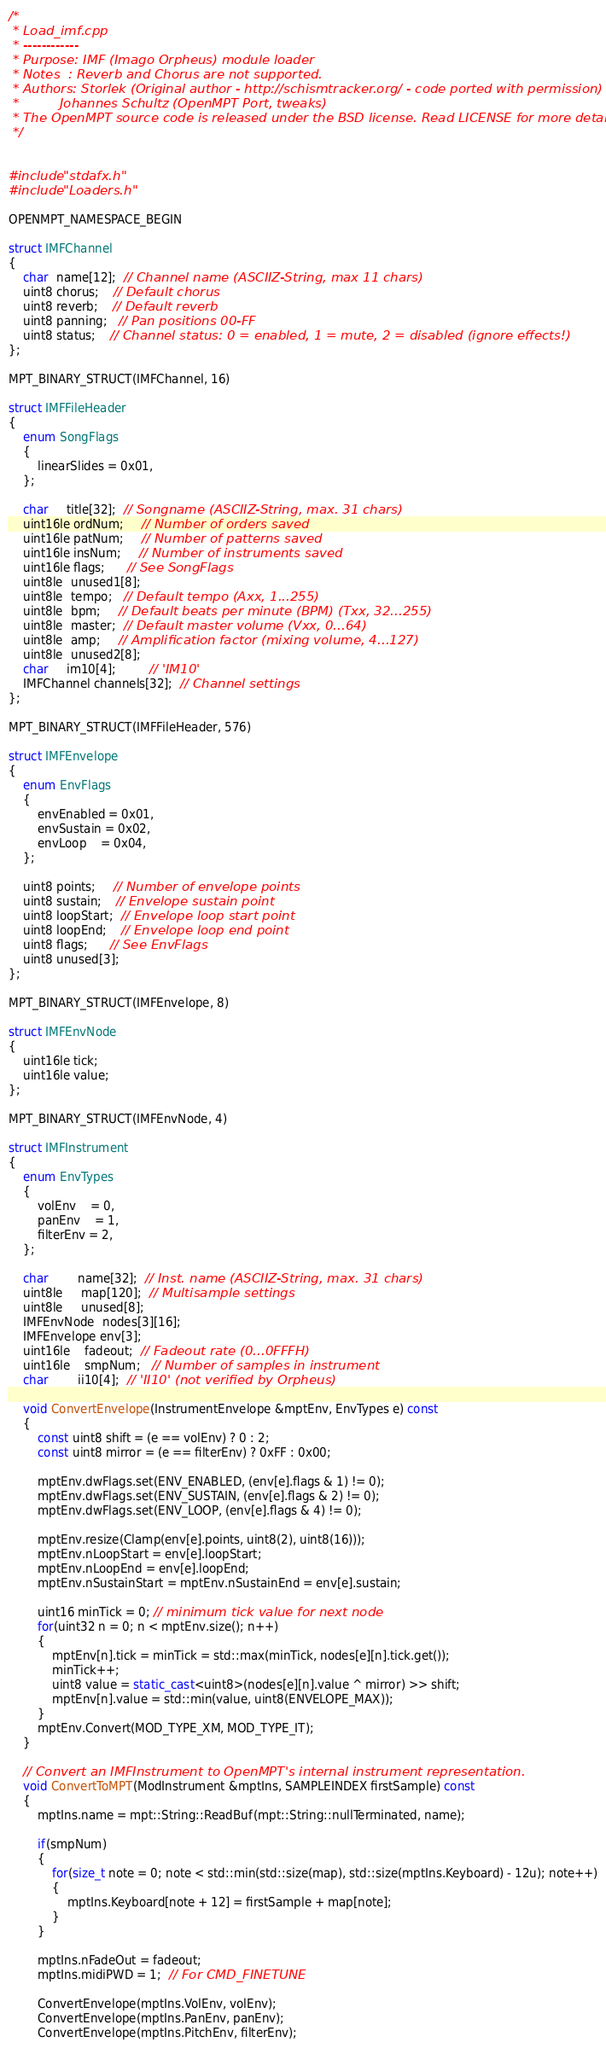Convert code to text. <code><loc_0><loc_0><loc_500><loc_500><_C++_>/*
 * Load_imf.cpp
 * ------------
 * Purpose: IMF (Imago Orpheus) module loader
 * Notes  : Reverb and Chorus are not supported.
 * Authors: Storlek (Original author - http://schismtracker.org/ - code ported with permission)
 *          Johannes Schultz (OpenMPT Port, tweaks)
 * The OpenMPT source code is released under the BSD license. Read LICENSE for more details.
 */


#include "stdafx.h"
#include "Loaders.h"

OPENMPT_NAMESPACE_BEGIN

struct IMFChannel
{
	char  name[12];  // Channel name (ASCIIZ-String, max 11 chars)
	uint8 chorus;    // Default chorus
	uint8 reverb;    // Default reverb
	uint8 panning;   // Pan positions 00-FF
	uint8 status;    // Channel status: 0 = enabled, 1 = mute, 2 = disabled (ignore effects!)
};

MPT_BINARY_STRUCT(IMFChannel, 16)

struct IMFFileHeader
{
	enum SongFlags
	{
		linearSlides = 0x01,
	};

	char     title[32];  // Songname (ASCIIZ-String, max. 31 chars)
	uint16le ordNum;     // Number of orders saved
	uint16le patNum;     // Number of patterns saved
	uint16le insNum;     // Number of instruments saved
	uint16le flags;      // See SongFlags
	uint8le  unused1[8];
	uint8le  tempo;   // Default tempo (Axx, 1...255)
	uint8le  bpm;     // Default beats per minute (BPM) (Txx, 32...255)
	uint8le  master;  // Default master volume (Vxx, 0...64)
	uint8le  amp;     // Amplification factor (mixing volume, 4...127)
	uint8le  unused2[8];
	char     im10[4];         // 'IM10'
	IMFChannel channels[32];  // Channel settings
};

MPT_BINARY_STRUCT(IMFFileHeader, 576)

struct IMFEnvelope
{
	enum EnvFlags
	{
		envEnabled = 0x01,
		envSustain = 0x02,
		envLoop    = 0x04,
	};

	uint8 points;     // Number of envelope points
	uint8 sustain;    // Envelope sustain point
	uint8 loopStart;  // Envelope loop start point
	uint8 loopEnd;    // Envelope loop end point
	uint8 flags;      // See EnvFlags
	uint8 unused[3];
};

MPT_BINARY_STRUCT(IMFEnvelope, 8)

struct IMFEnvNode
{
	uint16le tick;
	uint16le value;
};

MPT_BINARY_STRUCT(IMFEnvNode, 4)

struct IMFInstrument
{
	enum EnvTypes
	{
		volEnv    = 0,
		panEnv    = 1,
		filterEnv = 2,
	};

	char        name[32];  // Inst. name (ASCIIZ-String, max. 31 chars)
	uint8le     map[120];  // Multisample settings
	uint8le     unused[8];
	IMFEnvNode  nodes[3][16];
	IMFEnvelope env[3];
	uint16le    fadeout;  // Fadeout rate (0...0FFFH)
	uint16le    smpNum;   // Number of samples in instrument
	char        ii10[4];  // 'II10' (not verified by Orpheus)

	void ConvertEnvelope(InstrumentEnvelope &mptEnv, EnvTypes e) const
	{
		const uint8 shift = (e == volEnv) ? 0 : 2;
		const uint8 mirror = (e == filterEnv) ? 0xFF : 0x00;

		mptEnv.dwFlags.set(ENV_ENABLED, (env[e].flags & 1) != 0);
		mptEnv.dwFlags.set(ENV_SUSTAIN, (env[e].flags & 2) != 0);
		mptEnv.dwFlags.set(ENV_LOOP, (env[e].flags & 4) != 0);

		mptEnv.resize(Clamp(env[e].points, uint8(2), uint8(16)));
		mptEnv.nLoopStart = env[e].loopStart;
		mptEnv.nLoopEnd = env[e].loopEnd;
		mptEnv.nSustainStart = mptEnv.nSustainEnd = env[e].sustain;

		uint16 minTick = 0; // minimum tick value for next node
		for(uint32 n = 0; n < mptEnv.size(); n++)
		{
			mptEnv[n].tick = minTick = std::max(minTick, nodes[e][n].tick.get());
			minTick++;
			uint8 value = static_cast<uint8>(nodes[e][n].value ^ mirror) >> shift;
			mptEnv[n].value = std::min(value, uint8(ENVELOPE_MAX));
		}
		mptEnv.Convert(MOD_TYPE_XM, MOD_TYPE_IT);
	}

	// Convert an IMFInstrument to OpenMPT's internal instrument representation.
	void ConvertToMPT(ModInstrument &mptIns, SAMPLEINDEX firstSample) const
	{
		mptIns.name = mpt::String::ReadBuf(mpt::String::nullTerminated, name);

		if(smpNum)
		{
			for(size_t note = 0; note < std::min(std::size(map), std::size(mptIns.Keyboard) - 12u); note++)
			{
				mptIns.Keyboard[note + 12] = firstSample + map[note];
			}
		}

		mptIns.nFadeOut = fadeout;
		mptIns.midiPWD = 1;  // For CMD_FINETUNE

		ConvertEnvelope(mptIns.VolEnv, volEnv);
		ConvertEnvelope(mptIns.PanEnv, panEnv);
		ConvertEnvelope(mptIns.PitchEnv, filterEnv);</code> 